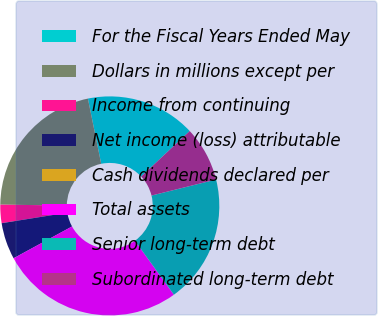<chart> <loc_0><loc_0><loc_500><loc_500><pie_chart><fcel>For the Fiscal Years Ended May<fcel>Dollars in millions except per<fcel>Income from continuing<fcel>Net income (loss) attributable<fcel>Cash dividends declared per<fcel>Total assets<fcel>Senior long-term debt<fcel>Subordinated long-term debt<nl><fcel>16.22%<fcel>21.62%<fcel>2.7%<fcel>5.41%<fcel>0.0%<fcel>27.02%<fcel>18.92%<fcel>8.11%<nl></chart> 